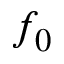Convert formula to latex. <formula><loc_0><loc_0><loc_500><loc_500>f _ { 0 }</formula> 